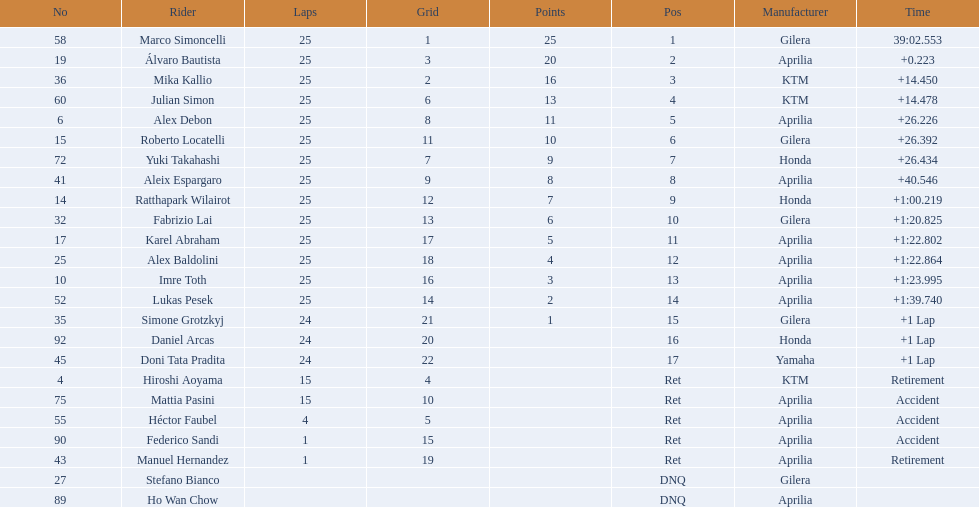What player number is marked #1 for the australian motorcycle grand prix? 58. Who is the rider that represents the #58 in the australian motorcycle grand prix? Marco Simoncelli. 